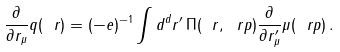Convert formula to latex. <formula><loc_0><loc_0><loc_500><loc_500>\frac { \partial } { \partial r _ { \mu } } q ( \ r ) = ( - e ) ^ { - 1 } \int d ^ { d } r ^ { \prime } \, \Pi ( \ r , \ r p ) \frac { \partial } { \partial r ^ { \prime } _ { \mu } } \mu ( \ r p ) \, .</formula> 